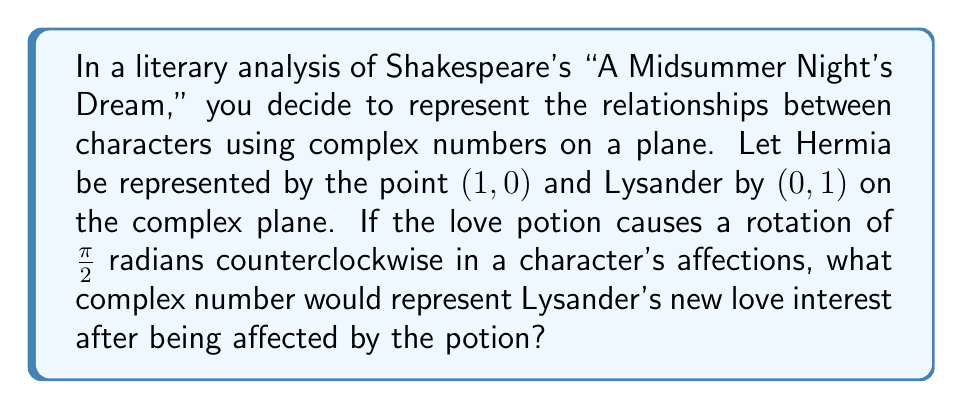Solve this math problem. To solve this problem, we'll follow these steps:

1) First, let's recall that on a complex plane:
   - The point (1,0) corresponds to the complex number 1 + 0i, or simply 1
   - The point (0,1) corresponds to the complex number 0 + 1i, or simply i

2) So, Hermia is represented by 1, and Lysander by i.

3) A rotation of π/2 radians (90 degrees) counterclockwise on the complex plane is equivalent to multiplying by i. This is because:

   $$i \cdot (a + bi) = ai + bi^2 = -b + ai$$

   Which rotates the point (a,b) to (-b,a), a 90-degree counterclockwise rotation.

4) Therefore, to find Lysander's new love interest after the potion, we multiply his original position by i:

   $$i \cdot i = i^2 = -1$$

5) This means that Lysander's affections have rotated from i to -1 on the complex plane.

6) The point -1 on the complex plane corresponds to the coordinates (-1,0).

In the context of the play, this could be interpreted as Lysander's affections moving from Hermia (1,0) to a point diametrically opposed to her on the unit circle, possibly representing Helena.
Answer: $-1$ or $(-1,0)$ on the complex plane 